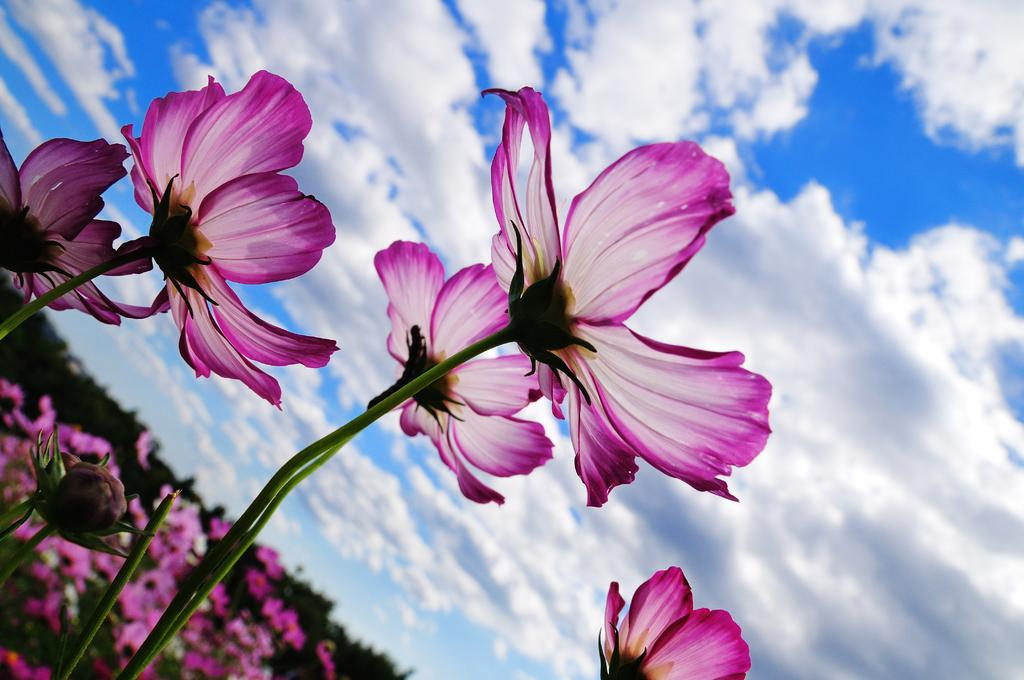What type of flowers can be seen in the image? There are purple color flowers in the image. What part of the flowers is connected to the stems? The stems are associated with the flowers. What can be seen in the background of the image? The sky is visible in the image. What is the color of the sky in the image? The sky is blue in color. What else is present in the sky in the image? There are clouds in the sky. What type of quill is being used to write on the flowers in the image? There is no quill or writing present in the image; it features flowers with stems and a blue sky with clouds. 